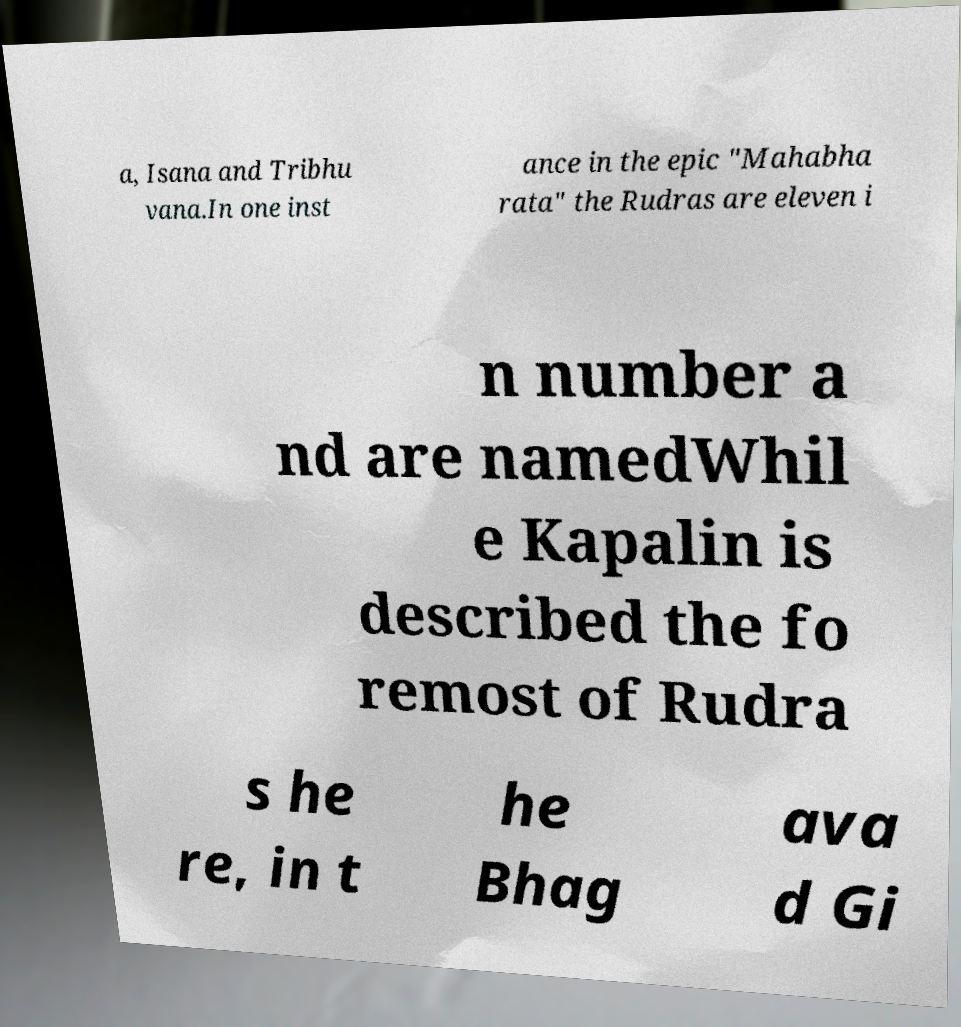Please identify and transcribe the text found in this image. a, Isana and Tribhu vana.In one inst ance in the epic "Mahabha rata" the Rudras are eleven i n number a nd are namedWhil e Kapalin is described the fo remost of Rudra s he re, in t he Bhag ava d Gi 